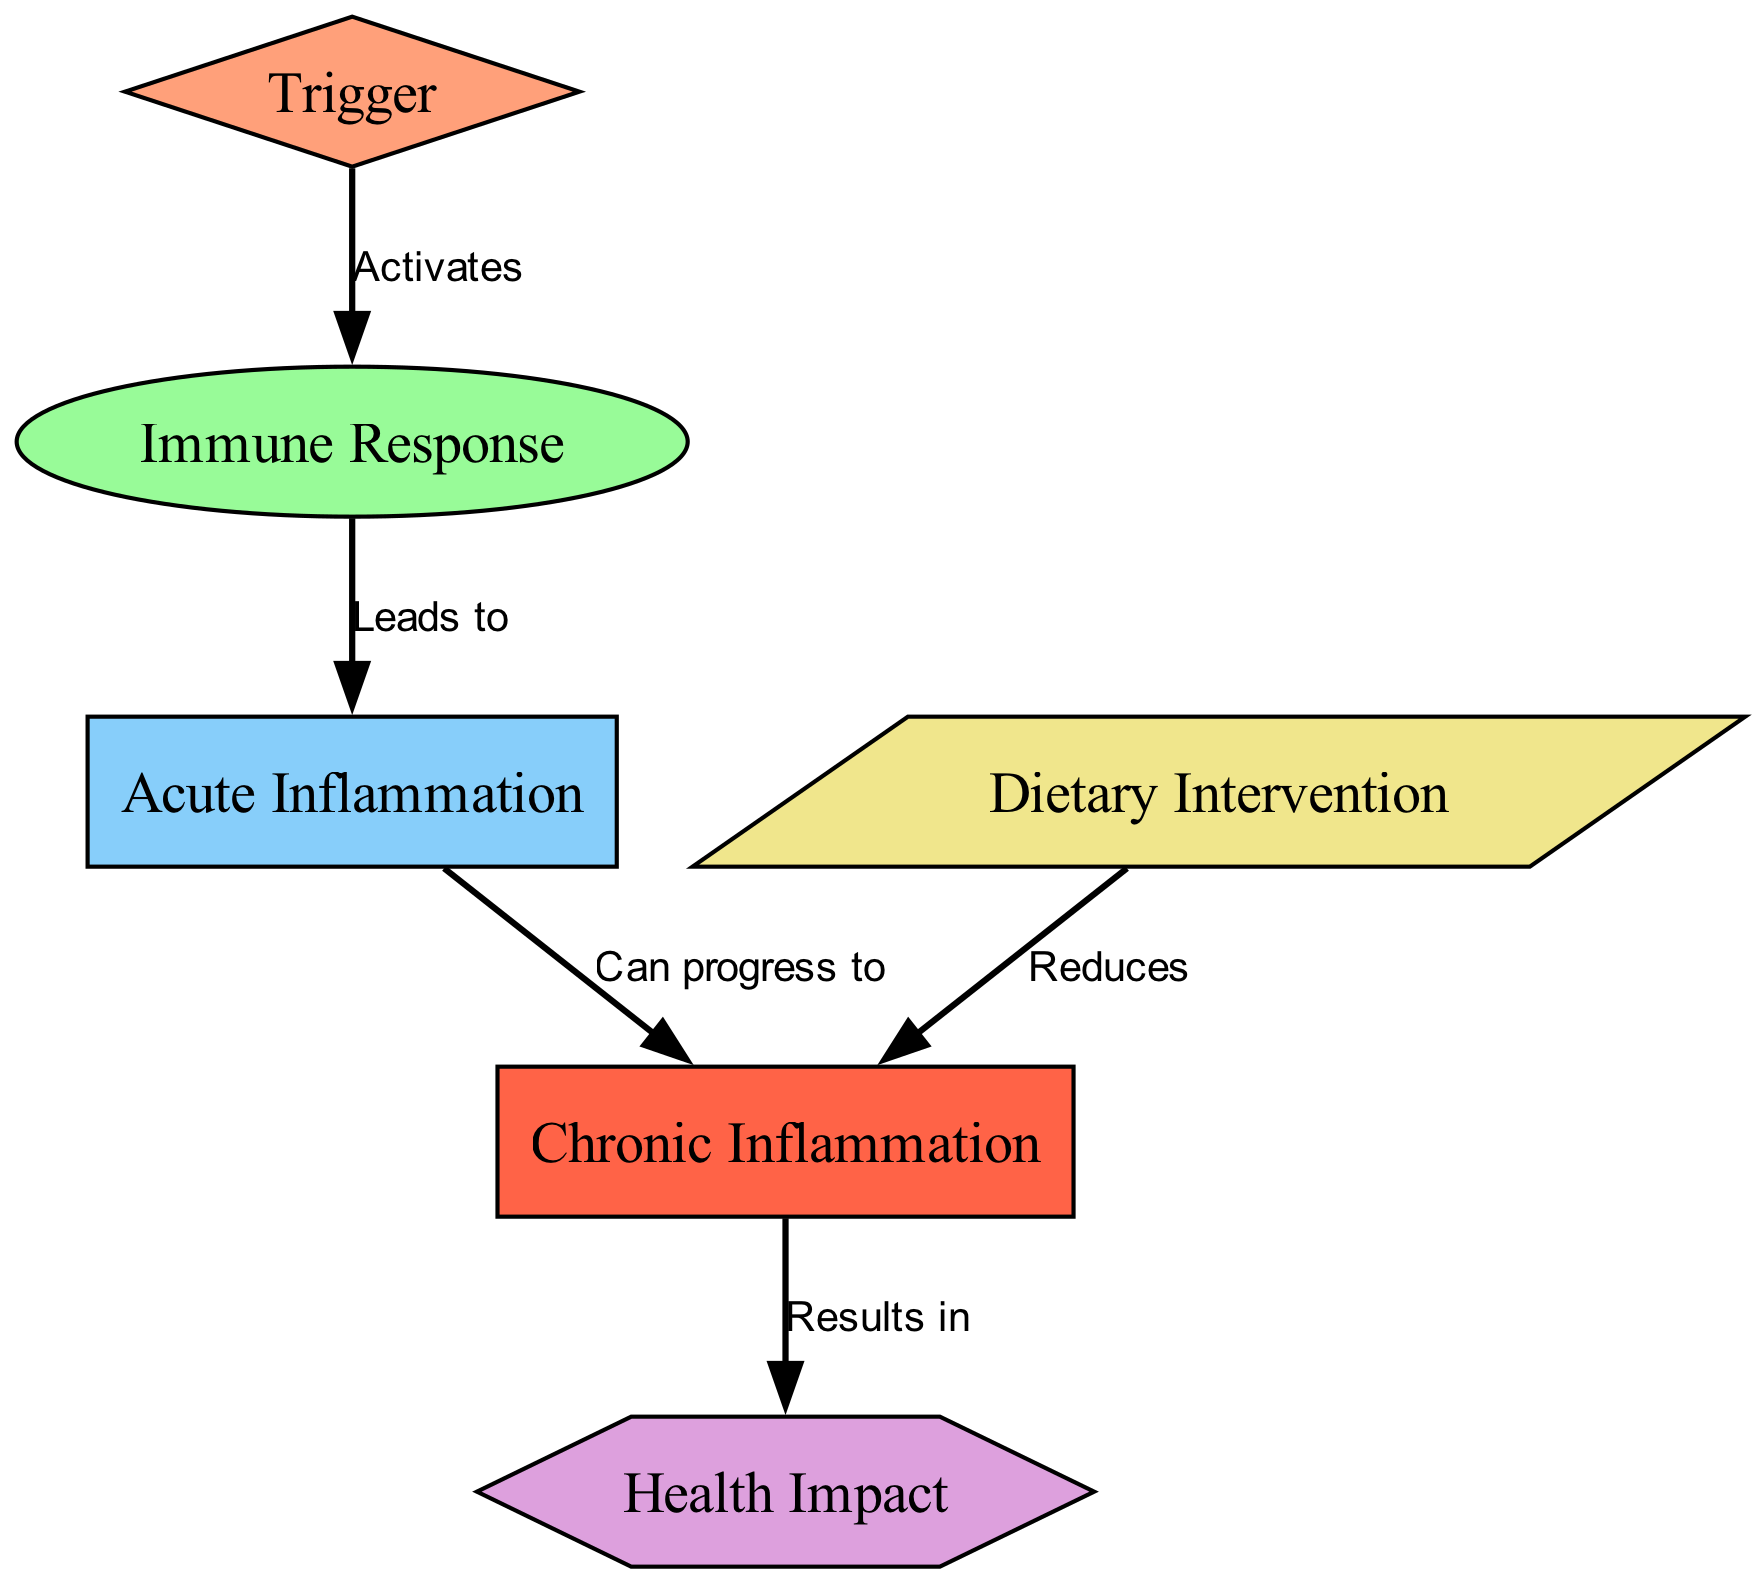What is the first step in the inflammation process? The diagram shows that the first step is labeled as "Trigger", indicating that an external factor initiates the process.
Answer: Trigger How many nodes are present in the diagram? By counting the unique items listed under "nodes," we find there are six distinct components.
Answer: 6 What does the "Immune Response" lead to? According to the directed edge, the "Immune Response" leads to "Acute Inflammation". This indicates a direct cause-and-effect relationship.
Answer: Acute Inflammation What can "Acute Inflammation" progress to? The diagram indicates that "Acute Inflammation" can progress to "Chronic Inflammation", suggesting a potential evolution of inflammation types.
Answer: Chronic Inflammation How do dietary interventions affect chronic inflammation? The diagram specifies that "Dietary Intervention" reduces "Chronic Inflammation", highlighting the beneficial role of nutrition in this context.
Answer: Reduces What is the endpoint of the inflammation process depicted in the diagram? The final outcome shown in the diagram stemming from "Chronic Inflammation" is "Health Impact", indicating that this is the ultimate effect of the entire inflammation process.
Answer: Health Impact What are the two types of inflammation mentioned in the diagram? The diagram lists "Acute Inflammation" and "Chronic Inflammation" as the bi-level categorization of inflammation, representing different states.
Answer: Acute Inflammation, Chronic Inflammation What relationship exists between "Chronic Inflammation" and "Health Impact"? The edge connecting these two nodes illustrates that "Chronic Inflammation" results in "Health Impact", implying that prolonged inflammation can affect health adversely.
Answer: Results in Which node is activated by the "Trigger"? The diagram shows that the "Trigger" activates the "Immune Response", indicating the initiating factor's role in the overall process.
Answer: Immune Response 